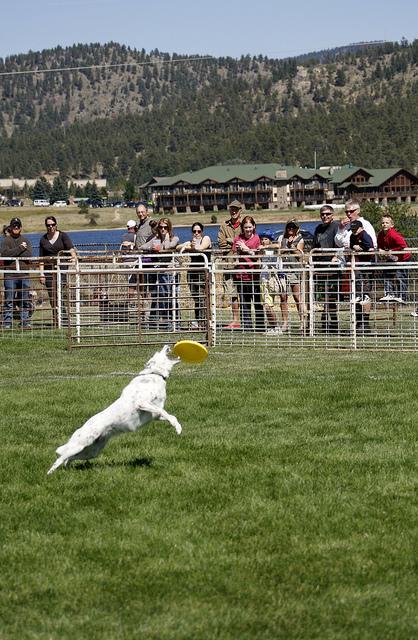Does the dog have its hind feet in the air?
Concise answer only. No. What type of terrain is in the background?
Concise answer only. Mountains. Are the people watching a dog race?
Keep it brief. No. 